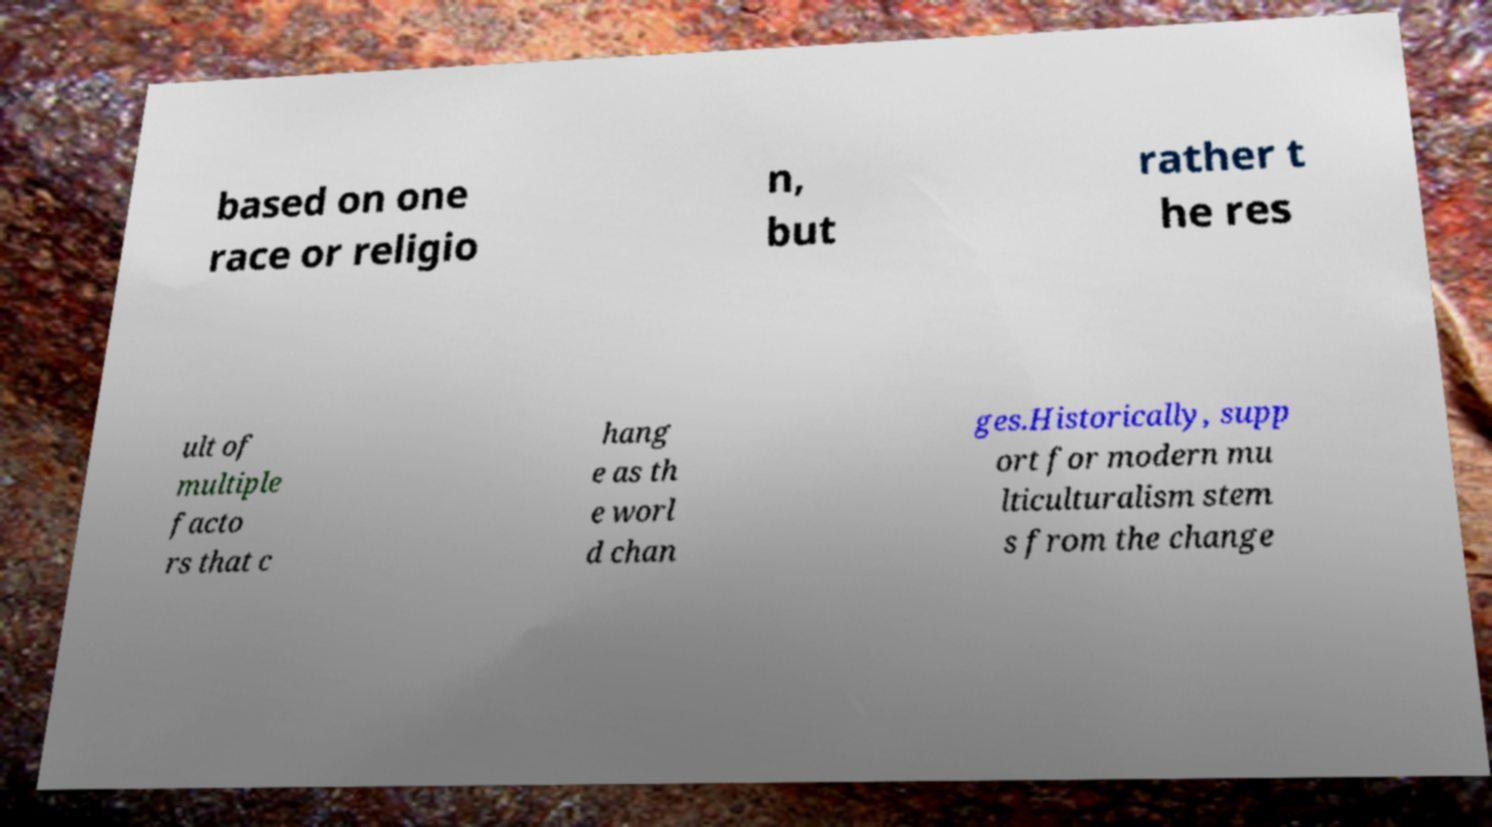Please read and relay the text visible in this image. What does it say? based on one race or religio n, but rather t he res ult of multiple facto rs that c hang e as th e worl d chan ges.Historically, supp ort for modern mu lticulturalism stem s from the change 